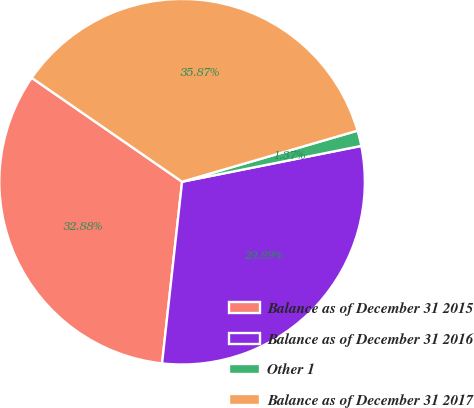Convert chart to OTSL. <chart><loc_0><loc_0><loc_500><loc_500><pie_chart><fcel>Balance as of December 31 2015<fcel>Balance as of December 31 2016<fcel>Other 1<fcel>Balance as of December 31 2017<nl><fcel>32.88%<fcel>29.89%<fcel>1.37%<fcel>35.87%<nl></chart> 